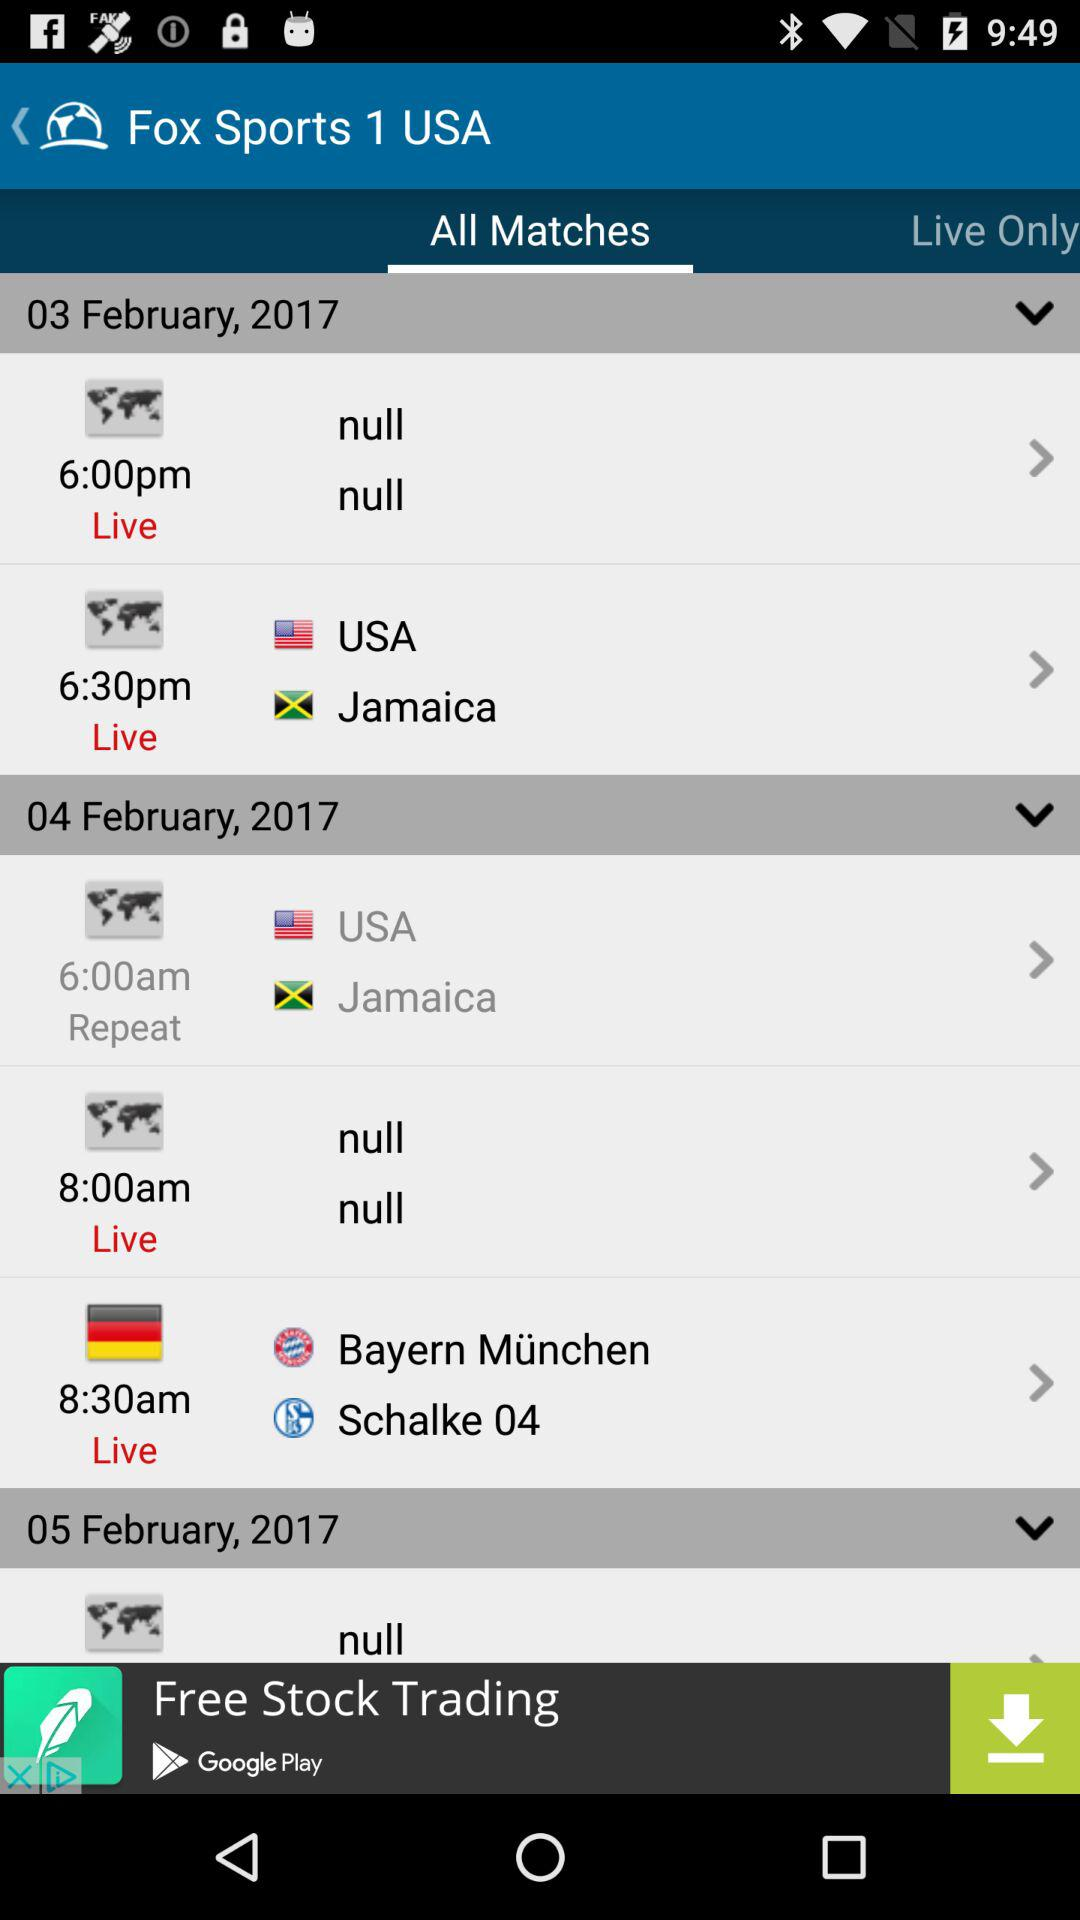How many matches are scheduled for the 05th of February?
Answer the question using a single word or phrase. 1 